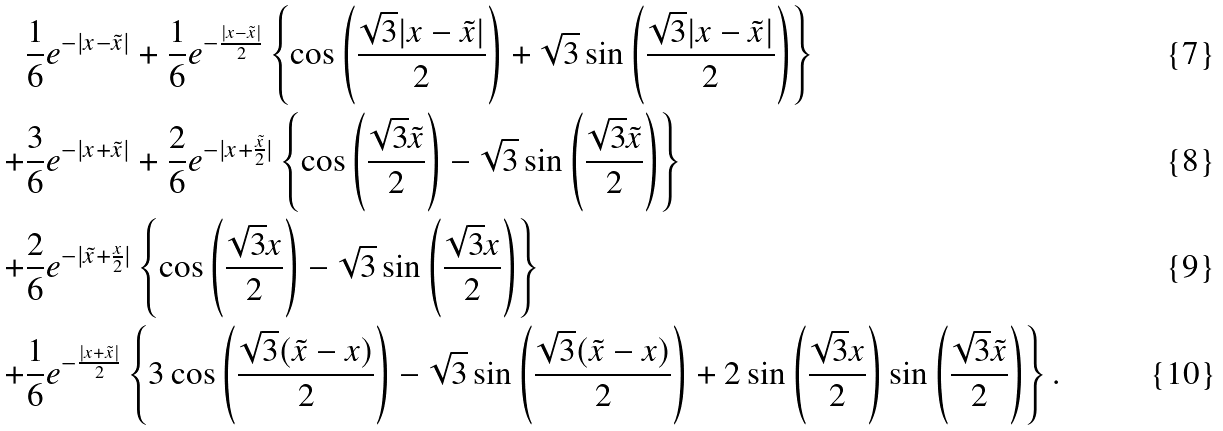<formula> <loc_0><loc_0><loc_500><loc_500>& \frac { 1 } { 6 } e ^ { - | x - \tilde { x } | } + \frac { 1 } { 6 } e ^ { - \frac { | x - \tilde { x } | } { 2 } } \left \{ \cos \left ( \frac { \sqrt { 3 } | x - \tilde { x } | } { 2 } \right ) + \sqrt { 3 } \sin \left ( \frac { \sqrt { 3 } | x - \tilde { x } | } { 2 } \right ) \right \} \\ + & \frac { 3 } { 6 } e ^ { - | x + \tilde { x } | } + \frac { 2 } { 6 } e ^ { - | x + \frac { \tilde { x } } { 2 } | } \left \{ \cos \left ( \frac { \sqrt { 3 } \tilde { x } } { 2 } \right ) - \sqrt { 3 } \sin \left ( \frac { \sqrt { 3 } \tilde { x } } { 2 } \right ) \right \} \\ + & \frac { 2 } { 6 } e ^ { - | \tilde { x } + \frac { x } { 2 } | } \left \{ \cos \left ( \frac { \sqrt { 3 } x } { 2 } \right ) - \sqrt { 3 } \sin \left ( \frac { \sqrt { 3 } x } { 2 } \right ) \right \} \\ + & \frac { 1 } { 6 } e ^ { - \frac { | x + \tilde { x } | } { 2 } } \left \{ 3 \cos \left ( \frac { \sqrt { 3 } ( \tilde { x } - x ) } { 2 } \right ) - \sqrt { 3 } \sin \left ( \frac { \sqrt { 3 } ( \tilde { x } - x ) } { 2 } \right ) + 2 \sin \left ( \frac { \sqrt { 3 } x } { 2 } \right ) \sin \left ( \frac { \sqrt { 3 } \tilde { x } } { 2 } \right ) \right \} .</formula> 